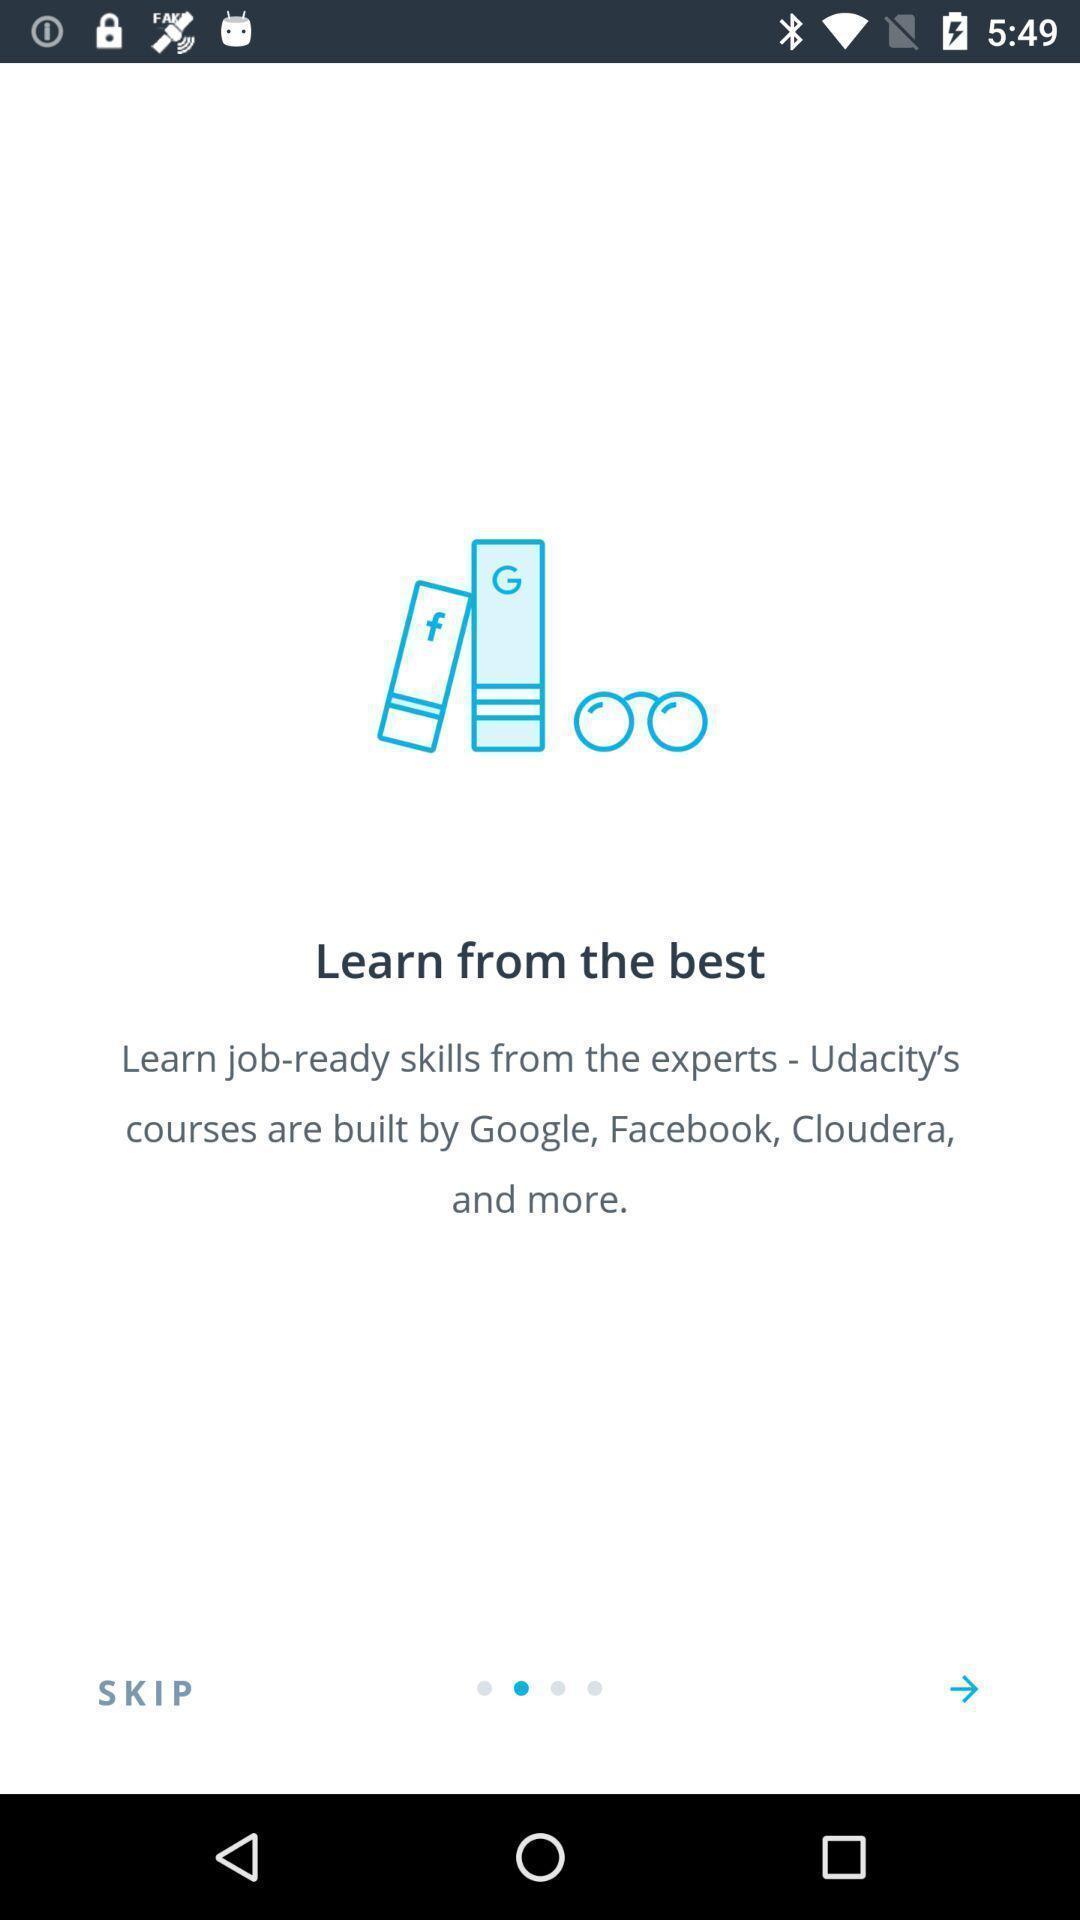What is the overall content of this screenshot? Welcome page of a learning app. 